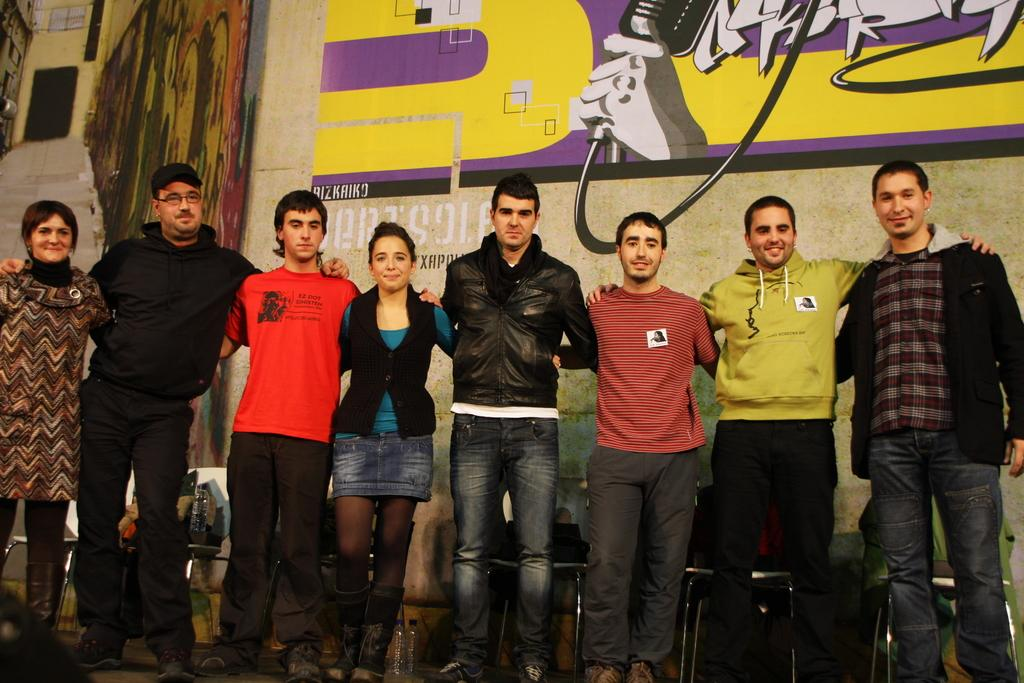How many people are in the image? There is a group of people in the image. What are the people doing in the image? The people are standing on the floor. What can be seen in the background of the image? There are chairs and a wall in the background of the image. What is on the wall in the image? Paintings are present on the wall. What color is the sock on the person's mouth in the image? There is no sock or person with a sock on their mouth in the image. 